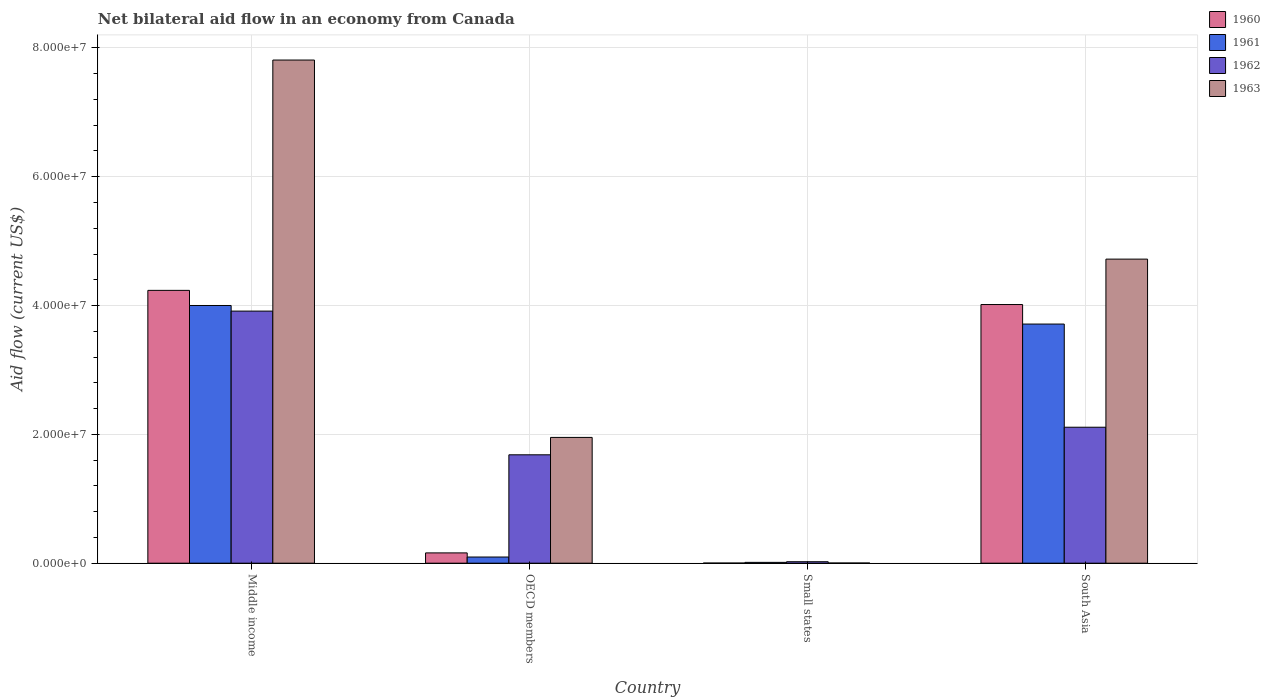How many different coloured bars are there?
Ensure brevity in your answer.  4. How many groups of bars are there?
Provide a succinct answer. 4. Are the number of bars per tick equal to the number of legend labels?
Make the answer very short. Yes. How many bars are there on the 4th tick from the left?
Offer a very short reply. 4. How many bars are there on the 1st tick from the right?
Give a very brief answer. 4. What is the label of the 2nd group of bars from the left?
Your answer should be compact. OECD members. In how many cases, is the number of bars for a given country not equal to the number of legend labels?
Ensure brevity in your answer.  0. Across all countries, what is the maximum net bilateral aid flow in 1961?
Provide a short and direct response. 4.00e+07. In which country was the net bilateral aid flow in 1962 minimum?
Your answer should be compact. Small states. What is the total net bilateral aid flow in 1963 in the graph?
Make the answer very short. 1.45e+08. What is the difference between the net bilateral aid flow in 1962 in OECD members and that in South Asia?
Give a very brief answer. -4.28e+06. What is the difference between the net bilateral aid flow in 1962 in OECD members and the net bilateral aid flow in 1961 in Middle income?
Offer a very short reply. -2.32e+07. What is the average net bilateral aid flow in 1961 per country?
Your answer should be very brief. 1.96e+07. What is the difference between the net bilateral aid flow of/in 1962 and net bilateral aid flow of/in 1963 in Small states?
Provide a succinct answer. 2.00e+05. In how many countries, is the net bilateral aid flow in 1960 greater than 44000000 US$?
Give a very brief answer. 0. What is the ratio of the net bilateral aid flow in 1961 in Small states to that in South Asia?
Your answer should be compact. 0. Is the net bilateral aid flow in 1961 in OECD members less than that in South Asia?
Your answer should be very brief. Yes. What is the difference between the highest and the second highest net bilateral aid flow in 1960?
Your response must be concise. 2.20e+06. What is the difference between the highest and the lowest net bilateral aid flow in 1962?
Your answer should be compact. 3.89e+07. In how many countries, is the net bilateral aid flow in 1962 greater than the average net bilateral aid flow in 1962 taken over all countries?
Keep it short and to the point. 2. Is the sum of the net bilateral aid flow in 1961 in Middle income and South Asia greater than the maximum net bilateral aid flow in 1960 across all countries?
Offer a very short reply. Yes. Is it the case that in every country, the sum of the net bilateral aid flow in 1960 and net bilateral aid flow in 1963 is greater than the sum of net bilateral aid flow in 1962 and net bilateral aid flow in 1961?
Make the answer very short. No. What does the 4th bar from the left in Small states represents?
Give a very brief answer. 1963. How many countries are there in the graph?
Ensure brevity in your answer.  4. What is the difference between two consecutive major ticks on the Y-axis?
Your answer should be compact. 2.00e+07. Does the graph contain grids?
Provide a succinct answer. Yes. How many legend labels are there?
Offer a very short reply. 4. How are the legend labels stacked?
Your response must be concise. Vertical. What is the title of the graph?
Make the answer very short. Net bilateral aid flow in an economy from Canada. Does "1996" appear as one of the legend labels in the graph?
Keep it short and to the point. No. What is the label or title of the Y-axis?
Give a very brief answer. Aid flow (current US$). What is the Aid flow (current US$) of 1960 in Middle income?
Offer a terse response. 4.24e+07. What is the Aid flow (current US$) in 1961 in Middle income?
Your response must be concise. 4.00e+07. What is the Aid flow (current US$) of 1962 in Middle income?
Keep it short and to the point. 3.91e+07. What is the Aid flow (current US$) in 1963 in Middle income?
Provide a short and direct response. 7.81e+07. What is the Aid flow (current US$) in 1960 in OECD members?
Give a very brief answer. 1.60e+06. What is the Aid flow (current US$) of 1961 in OECD members?
Give a very brief answer. 9.60e+05. What is the Aid flow (current US$) of 1962 in OECD members?
Your answer should be very brief. 1.68e+07. What is the Aid flow (current US$) of 1963 in OECD members?
Keep it short and to the point. 1.95e+07. What is the Aid flow (current US$) of 1960 in Small states?
Provide a short and direct response. 2.00e+04. What is the Aid flow (current US$) of 1961 in Small states?
Give a very brief answer. 1.30e+05. What is the Aid flow (current US$) of 1962 in Small states?
Offer a terse response. 2.30e+05. What is the Aid flow (current US$) of 1963 in Small states?
Your answer should be very brief. 3.00e+04. What is the Aid flow (current US$) of 1960 in South Asia?
Ensure brevity in your answer.  4.02e+07. What is the Aid flow (current US$) in 1961 in South Asia?
Give a very brief answer. 3.71e+07. What is the Aid flow (current US$) of 1962 in South Asia?
Give a very brief answer. 2.11e+07. What is the Aid flow (current US$) of 1963 in South Asia?
Offer a terse response. 4.72e+07. Across all countries, what is the maximum Aid flow (current US$) of 1960?
Your answer should be very brief. 4.24e+07. Across all countries, what is the maximum Aid flow (current US$) in 1961?
Offer a terse response. 4.00e+07. Across all countries, what is the maximum Aid flow (current US$) of 1962?
Your answer should be very brief. 3.91e+07. Across all countries, what is the maximum Aid flow (current US$) in 1963?
Your response must be concise. 7.81e+07. Across all countries, what is the minimum Aid flow (current US$) of 1960?
Ensure brevity in your answer.  2.00e+04. Across all countries, what is the minimum Aid flow (current US$) of 1963?
Give a very brief answer. 3.00e+04. What is the total Aid flow (current US$) of 1960 in the graph?
Your answer should be very brief. 8.41e+07. What is the total Aid flow (current US$) in 1961 in the graph?
Keep it short and to the point. 7.82e+07. What is the total Aid flow (current US$) of 1962 in the graph?
Offer a terse response. 7.73e+07. What is the total Aid flow (current US$) in 1963 in the graph?
Make the answer very short. 1.45e+08. What is the difference between the Aid flow (current US$) of 1960 in Middle income and that in OECD members?
Make the answer very short. 4.08e+07. What is the difference between the Aid flow (current US$) of 1961 in Middle income and that in OECD members?
Your answer should be very brief. 3.90e+07. What is the difference between the Aid flow (current US$) in 1962 in Middle income and that in OECD members?
Offer a very short reply. 2.23e+07. What is the difference between the Aid flow (current US$) in 1963 in Middle income and that in OECD members?
Your answer should be compact. 5.86e+07. What is the difference between the Aid flow (current US$) of 1960 in Middle income and that in Small states?
Provide a short and direct response. 4.23e+07. What is the difference between the Aid flow (current US$) in 1961 in Middle income and that in Small states?
Give a very brief answer. 3.99e+07. What is the difference between the Aid flow (current US$) of 1962 in Middle income and that in Small states?
Offer a terse response. 3.89e+07. What is the difference between the Aid flow (current US$) in 1963 in Middle income and that in Small states?
Your response must be concise. 7.81e+07. What is the difference between the Aid flow (current US$) of 1960 in Middle income and that in South Asia?
Your response must be concise. 2.20e+06. What is the difference between the Aid flow (current US$) in 1961 in Middle income and that in South Asia?
Offer a terse response. 2.88e+06. What is the difference between the Aid flow (current US$) of 1962 in Middle income and that in South Asia?
Keep it short and to the point. 1.80e+07. What is the difference between the Aid flow (current US$) in 1963 in Middle income and that in South Asia?
Your response must be concise. 3.09e+07. What is the difference between the Aid flow (current US$) in 1960 in OECD members and that in Small states?
Offer a terse response. 1.58e+06. What is the difference between the Aid flow (current US$) in 1961 in OECD members and that in Small states?
Make the answer very short. 8.30e+05. What is the difference between the Aid flow (current US$) in 1962 in OECD members and that in Small states?
Your response must be concise. 1.66e+07. What is the difference between the Aid flow (current US$) in 1963 in OECD members and that in Small states?
Your answer should be compact. 1.95e+07. What is the difference between the Aid flow (current US$) of 1960 in OECD members and that in South Asia?
Offer a terse response. -3.86e+07. What is the difference between the Aid flow (current US$) in 1961 in OECD members and that in South Asia?
Provide a short and direct response. -3.62e+07. What is the difference between the Aid flow (current US$) of 1962 in OECD members and that in South Asia?
Offer a very short reply. -4.28e+06. What is the difference between the Aid flow (current US$) in 1963 in OECD members and that in South Asia?
Ensure brevity in your answer.  -2.77e+07. What is the difference between the Aid flow (current US$) in 1960 in Small states and that in South Asia?
Your answer should be very brief. -4.01e+07. What is the difference between the Aid flow (current US$) of 1961 in Small states and that in South Asia?
Provide a short and direct response. -3.70e+07. What is the difference between the Aid flow (current US$) in 1962 in Small states and that in South Asia?
Your answer should be very brief. -2.09e+07. What is the difference between the Aid flow (current US$) of 1963 in Small states and that in South Asia?
Your answer should be compact. -4.72e+07. What is the difference between the Aid flow (current US$) of 1960 in Middle income and the Aid flow (current US$) of 1961 in OECD members?
Make the answer very short. 4.14e+07. What is the difference between the Aid flow (current US$) of 1960 in Middle income and the Aid flow (current US$) of 1962 in OECD members?
Make the answer very short. 2.55e+07. What is the difference between the Aid flow (current US$) of 1960 in Middle income and the Aid flow (current US$) of 1963 in OECD members?
Make the answer very short. 2.28e+07. What is the difference between the Aid flow (current US$) of 1961 in Middle income and the Aid flow (current US$) of 1962 in OECD members?
Give a very brief answer. 2.32e+07. What is the difference between the Aid flow (current US$) of 1961 in Middle income and the Aid flow (current US$) of 1963 in OECD members?
Ensure brevity in your answer.  2.05e+07. What is the difference between the Aid flow (current US$) in 1962 in Middle income and the Aid flow (current US$) in 1963 in OECD members?
Your answer should be very brief. 1.96e+07. What is the difference between the Aid flow (current US$) of 1960 in Middle income and the Aid flow (current US$) of 1961 in Small states?
Make the answer very short. 4.22e+07. What is the difference between the Aid flow (current US$) of 1960 in Middle income and the Aid flow (current US$) of 1962 in Small states?
Your response must be concise. 4.21e+07. What is the difference between the Aid flow (current US$) of 1960 in Middle income and the Aid flow (current US$) of 1963 in Small states?
Your response must be concise. 4.23e+07. What is the difference between the Aid flow (current US$) of 1961 in Middle income and the Aid flow (current US$) of 1962 in Small states?
Your response must be concise. 3.98e+07. What is the difference between the Aid flow (current US$) of 1961 in Middle income and the Aid flow (current US$) of 1963 in Small states?
Offer a very short reply. 4.00e+07. What is the difference between the Aid flow (current US$) of 1962 in Middle income and the Aid flow (current US$) of 1963 in Small states?
Your answer should be very brief. 3.91e+07. What is the difference between the Aid flow (current US$) of 1960 in Middle income and the Aid flow (current US$) of 1961 in South Asia?
Provide a short and direct response. 5.23e+06. What is the difference between the Aid flow (current US$) in 1960 in Middle income and the Aid flow (current US$) in 1962 in South Asia?
Offer a very short reply. 2.12e+07. What is the difference between the Aid flow (current US$) in 1960 in Middle income and the Aid flow (current US$) in 1963 in South Asia?
Ensure brevity in your answer.  -4.85e+06. What is the difference between the Aid flow (current US$) of 1961 in Middle income and the Aid flow (current US$) of 1962 in South Asia?
Offer a very short reply. 1.89e+07. What is the difference between the Aid flow (current US$) of 1961 in Middle income and the Aid flow (current US$) of 1963 in South Asia?
Provide a short and direct response. -7.20e+06. What is the difference between the Aid flow (current US$) of 1962 in Middle income and the Aid flow (current US$) of 1963 in South Asia?
Give a very brief answer. -8.07e+06. What is the difference between the Aid flow (current US$) in 1960 in OECD members and the Aid flow (current US$) in 1961 in Small states?
Offer a very short reply. 1.47e+06. What is the difference between the Aid flow (current US$) of 1960 in OECD members and the Aid flow (current US$) of 1962 in Small states?
Your answer should be very brief. 1.37e+06. What is the difference between the Aid flow (current US$) of 1960 in OECD members and the Aid flow (current US$) of 1963 in Small states?
Ensure brevity in your answer.  1.57e+06. What is the difference between the Aid flow (current US$) of 1961 in OECD members and the Aid flow (current US$) of 1962 in Small states?
Offer a very short reply. 7.30e+05. What is the difference between the Aid flow (current US$) of 1961 in OECD members and the Aid flow (current US$) of 1963 in Small states?
Keep it short and to the point. 9.30e+05. What is the difference between the Aid flow (current US$) in 1962 in OECD members and the Aid flow (current US$) in 1963 in Small states?
Provide a short and direct response. 1.68e+07. What is the difference between the Aid flow (current US$) of 1960 in OECD members and the Aid flow (current US$) of 1961 in South Asia?
Provide a succinct answer. -3.55e+07. What is the difference between the Aid flow (current US$) in 1960 in OECD members and the Aid flow (current US$) in 1962 in South Asia?
Your answer should be compact. -1.95e+07. What is the difference between the Aid flow (current US$) in 1960 in OECD members and the Aid flow (current US$) in 1963 in South Asia?
Ensure brevity in your answer.  -4.56e+07. What is the difference between the Aid flow (current US$) in 1961 in OECD members and the Aid flow (current US$) in 1962 in South Asia?
Provide a short and direct response. -2.02e+07. What is the difference between the Aid flow (current US$) of 1961 in OECD members and the Aid flow (current US$) of 1963 in South Asia?
Offer a very short reply. -4.62e+07. What is the difference between the Aid flow (current US$) of 1962 in OECD members and the Aid flow (current US$) of 1963 in South Asia?
Ensure brevity in your answer.  -3.04e+07. What is the difference between the Aid flow (current US$) of 1960 in Small states and the Aid flow (current US$) of 1961 in South Asia?
Ensure brevity in your answer.  -3.71e+07. What is the difference between the Aid flow (current US$) of 1960 in Small states and the Aid flow (current US$) of 1962 in South Asia?
Offer a very short reply. -2.11e+07. What is the difference between the Aid flow (current US$) in 1960 in Small states and the Aid flow (current US$) in 1963 in South Asia?
Keep it short and to the point. -4.72e+07. What is the difference between the Aid flow (current US$) of 1961 in Small states and the Aid flow (current US$) of 1962 in South Asia?
Ensure brevity in your answer.  -2.10e+07. What is the difference between the Aid flow (current US$) in 1961 in Small states and the Aid flow (current US$) in 1963 in South Asia?
Offer a very short reply. -4.71e+07. What is the difference between the Aid flow (current US$) of 1962 in Small states and the Aid flow (current US$) of 1963 in South Asia?
Make the answer very short. -4.70e+07. What is the average Aid flow (current US$) in 1960 per country?
Provide a short and direct response. 2.10e+07. What is the average Aid flow (current US$) of 1961 per country?
Offer a terse response. 1.96e+07. What is the average Aid flow (current US$) in 1962 per country?
Make the answer very short. 1.93e+07. What is the average Aid flow (current US$) of 1963 per country?
Provide a succinct answer. 3.62e+07. What is the difference between the Aid flow (current US$) of 1960 and Aid flow (current US$) of 1961 in Middle income?
Your response must be concise. 2.35e+06. What is the difference between the Aid flow (current US$) in 1960 and Aid flow (current US$) in 1962 in Middle income?
Give a very brief answer. 3.22e+06. What is the difference between the Aid flow (current US$) of 1960 and Aid flow (current US$) of 1963 in Middle income?
Ensure brevity in your answer.  -3.58e+07. What is the difference between the Aid flow (current US$) in 1961 and Aid flow (current US$) in 1962 in Middle income?
Offer a terse response. 8.70e+05. What is the difference between the Aid flow (current US$) in 1961 and Aid flow (current US$) in 1963 in Middle income?
Your response must be concise. -3.81e+07. What is the difference between the Aid flow (current US$) in 1962 and Aid flow (current US$) in 1963 in Middle income?
Provide a short and direct response. -3.90e+07. What is the difference between the Aid flow (current US$) of 1960 and Aid flow (current US$) of 1961 in OECD members?
Make the answer very short. 6.40e+05. What is the difference between the Aid flow (current US$) of 1960 and Aid flow (current US$) of 1962 in OECD members?
Provide a short and direct response. -1.52e+07. What is the difference between the Aid flow (current US$) of 1960 and Aid flow (current US$) of 1963 in OECD members?
Offer a terse response. -1.79e+07. What is the difference between the Aid flow (current US$) in 1961 and Aid flow (current US$) in 1962 in OECD members?
Offer a very short reply. -1.59e+07. What is the difference between the Aid flow (current US$) of 1961 and Aid flow (current US$) of 1963 in OECD members?
Keep it short and to the point. -1.86e+07. What is the difference between the Aid flow (current US$) in 1962 and Aid flow (current US$) in 1963 in OECD members?
Your answer should be very brief. -2.70e+06. What is the difference between the Aid flow (current US$) in 1960 and Aid flow (current US$) in 1961 in Small states?
Make the answer very short. -1.10e+05. What is the difference between the Aid flow (current US$) of 1960 and Aid flow (current US$) of 1962 in Small states?
Give a very brief answer. -2.10e+05. What is the difference between the Aid flow (current US$) of 1960 and Aid flow (current US$) of 1963 in Small states?
Offer a terse response. -10000. What is the difference between the Aid flow (current US$) of 1962 and Aid flow (current US$) of 1963 in Small states?
Offer a terse response. 2.00e+05. What is the difference between the Aid flow (current US$) of 1960 and Aid flow (current US$) of 1961 in South Asia?
Make the answer very short. 3.03e+06. What is the difference between the Aid flow (current US$) in 1960 and Aid flow (current US$) in 1962 in South Asia?
Offer a very short reply. 1.90e+07. What is the difference between the Aid flow (current US$) of 1960 and Aid flow (current US$) of 1963 in South Asia?
Your response must be concise. -7.05e+06. What is the difference between the Aid flow (current US$) of 1961 and Aid flow (current US$) of 1962 in South Asia?
Your answer should be compact. 1.60e+07. What is the difference between the Aid flow (current US$) in 1961 and Aid flow (current US$) in 1963 in South Asia?
Offer a terse response. -1.01e+07. What is the difference between the Aid flow (current US$) in 1962 and Aid flow (current US$) in 1963 in South Asia?
Make the answer very short. -2.61e+07. What is the ratio of the Aid flow (current US$) of 1960 in Middle income to that in OECD members?
Keep it short and to the point. 26.48. What is the ratio of the Aid flow (current US$) of 1961 in Middle income to that in OECD members?
Offer a very short reply. 41.68. What is the ratio of the Aid flow (current US$) of 1962 in Middle income to that in OECD members?
Make the answer very short. 2.33. What is the ratio of the Aid flow (current US$) of 1963 in Middle income to that in OECD members?
Make the answer very short. 4. What is the ratio of the Aid flow (current US$) of 1960 in Middle income to that in Small states?
Offer a very short reply. 2118. What is the ratio of the Aid flow (current US$) of 1961 in Middle income to that in Small states?
Offer a very short reply. 307.77. What is the ratio of the Aid flow (current US$) of 1962 in Middle income to that in Small states?
Offer a terse response. 170.17. What is the ratio of the Aid flow (current US$) of 1963 in Middle income to that in Small states?
Ensure brevity in your answer.  2604. What is the ratio of the Aid flow (current US$) in 1960 in Middle income to that in South Asia?
Your response must be concise. 1.05. What is the ratio of the Aid flow (current US$) of 1961 in Middle income to that in South Asia?
Your response must be concise. 1.08. What is the ratio of the Aid flow (current US$) of 1962 in Middle income to that in South Asia?
Your answer should be compact. 1.85. What is the ratio of the Aid flow (current US$) of 1963 in Middle income to that in South Asia?
Your answer should be compact. 1.65. What is the ratio of the Aid flow (current US$) of 1960 in OECD members to that in Small states?
Offer a very short reply. 80. What is the ratio of the Aid flow (current US$) of 1961 in OECD members to that in Small states?
Your answer should be compact. 7.38. What is the ratio of the Aid flow (current US$) of 1962 in OECD members to that in Small states?
Offer a very short reply. 73.17. What is the ratio of the Aid flow (current US$) in 1963 in OECD members to that in Small states?
Provide a succinct answer. 651. What is the ratio of the Aid flow (current US$) in 1960 in OECD members to that in South Asia?
Offer a terse response. 0.04. What is the ratio of the Aid flow (current US$) in 1961 in OECD members to that in South Asia?
Make the answer very short. 0.03. What is the ratio of the Aid flow (current US$) in 1962 in OECD members to that in South Asia?
Your answer should be compact. 0.8. What is the ratio of the Aid flow (current US$) of 1963 in OECD members to that in South Asia?
Your response must be concise. 0.41. What is the ratio of the Aid flow (current US$) of 1960 in Small states to that in South Asia?
Ensure brevity in your answer.  0. What is the ratio of the Aid flow (current US$) of 1961 in Small states to that in South Asia?
Give a very brief answer. 0. What is the ratio of the Aid flow (current US$) in 1962 in Small states to that in South Asia?
Offer a terse response. 0.01. What is the ratio of the Aid flow (current US$) of 1963 in Small states to that in South Asia?
Ensure brevity in your answer.  0. What is the difference between the highest and the second highest Aid flow (current US$) in 1960?
Your answer should be compact. 2.20e+06. What is the difference between the highest and the second highest Aid flow (current US$) of 1961?
Keep it short and to the point. 2.88e+06. What is the difference between the highest and the second highest Aid flow (current US$) in 1962?
Offer a terse response. 1.80e+07. What is the difference between the highest and the second highest Aid flow (current US$) of 1963?
Your answer should be compact. 3.09e+07. What is the difference between the highest and the lowest Aid flow (current US$) of 1960?
Make the answer very short. 4.23e+07. What is the difference between the highest and the lowest Aid flow (current US$) in 1961?
Provide a succinct answer. 3.99e+07. What is the difference between the highest and the lowest Aid flow (current US$) in 1962?
Provide a succinct answer. 3.89e+07. What is the difference between the highest and the lowest Aid flow (current US$) of 1963?
Provide a short and direct response. 7.81e+07. 